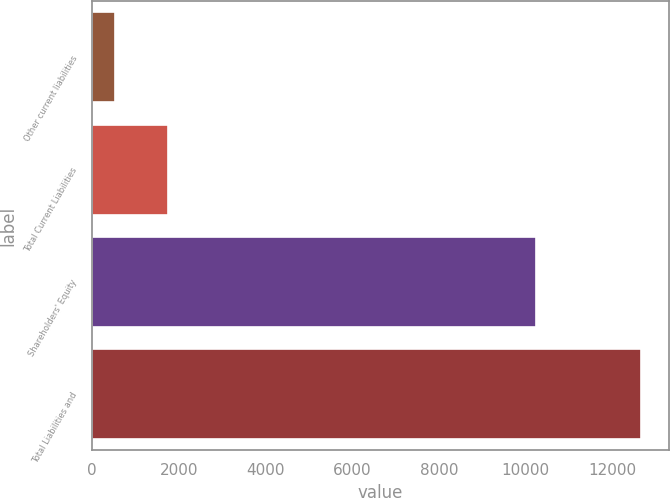Convert chart. <chart><loc_0><loc_0><loc_500><loc_500><bar_chart><fcel>Other current liabilities<fcel>Total Current Liabilities<fcel>Shareholders' Equity<fcel>Total Liabilities and<nl><fcel>523<fcel>1737.6<fcel>10233<fcel>12669<nl></chart> 